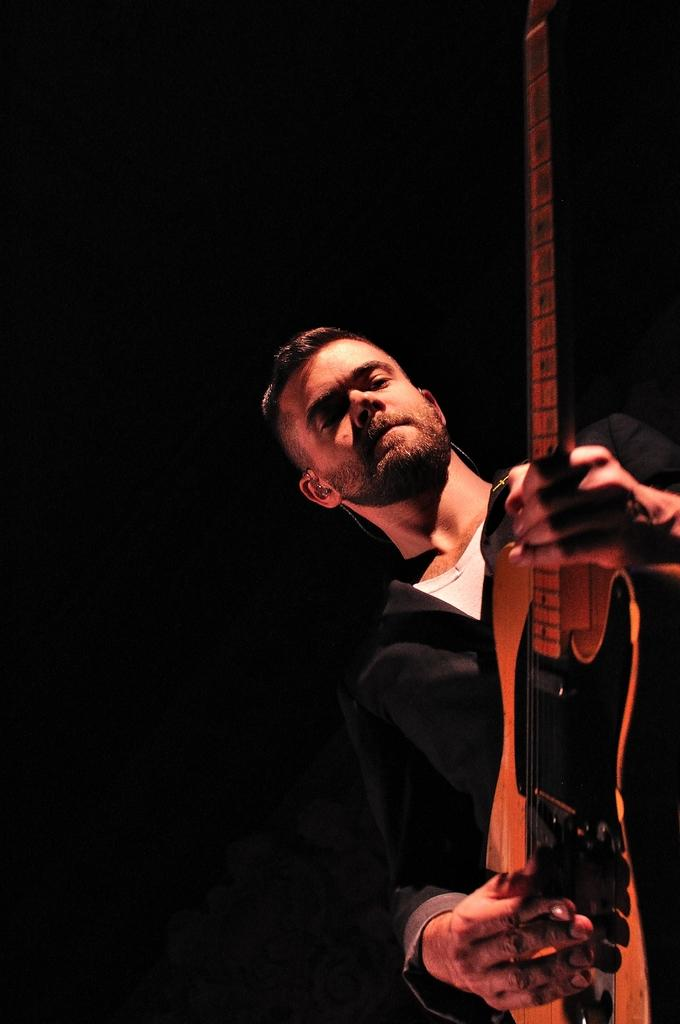Who is the main subject in the image? There is a man in the image. What is the man wearing? The man is wearing a black and white dress. What object is the man holding in the image? The man is holding a guitar. What is the man doing with the guitar? The man is playing the guitar. What type of cheese is the man eating while playing the guitar in the image? There is no cheese present in the image, and the man is not eating anything while playing the guitar. 